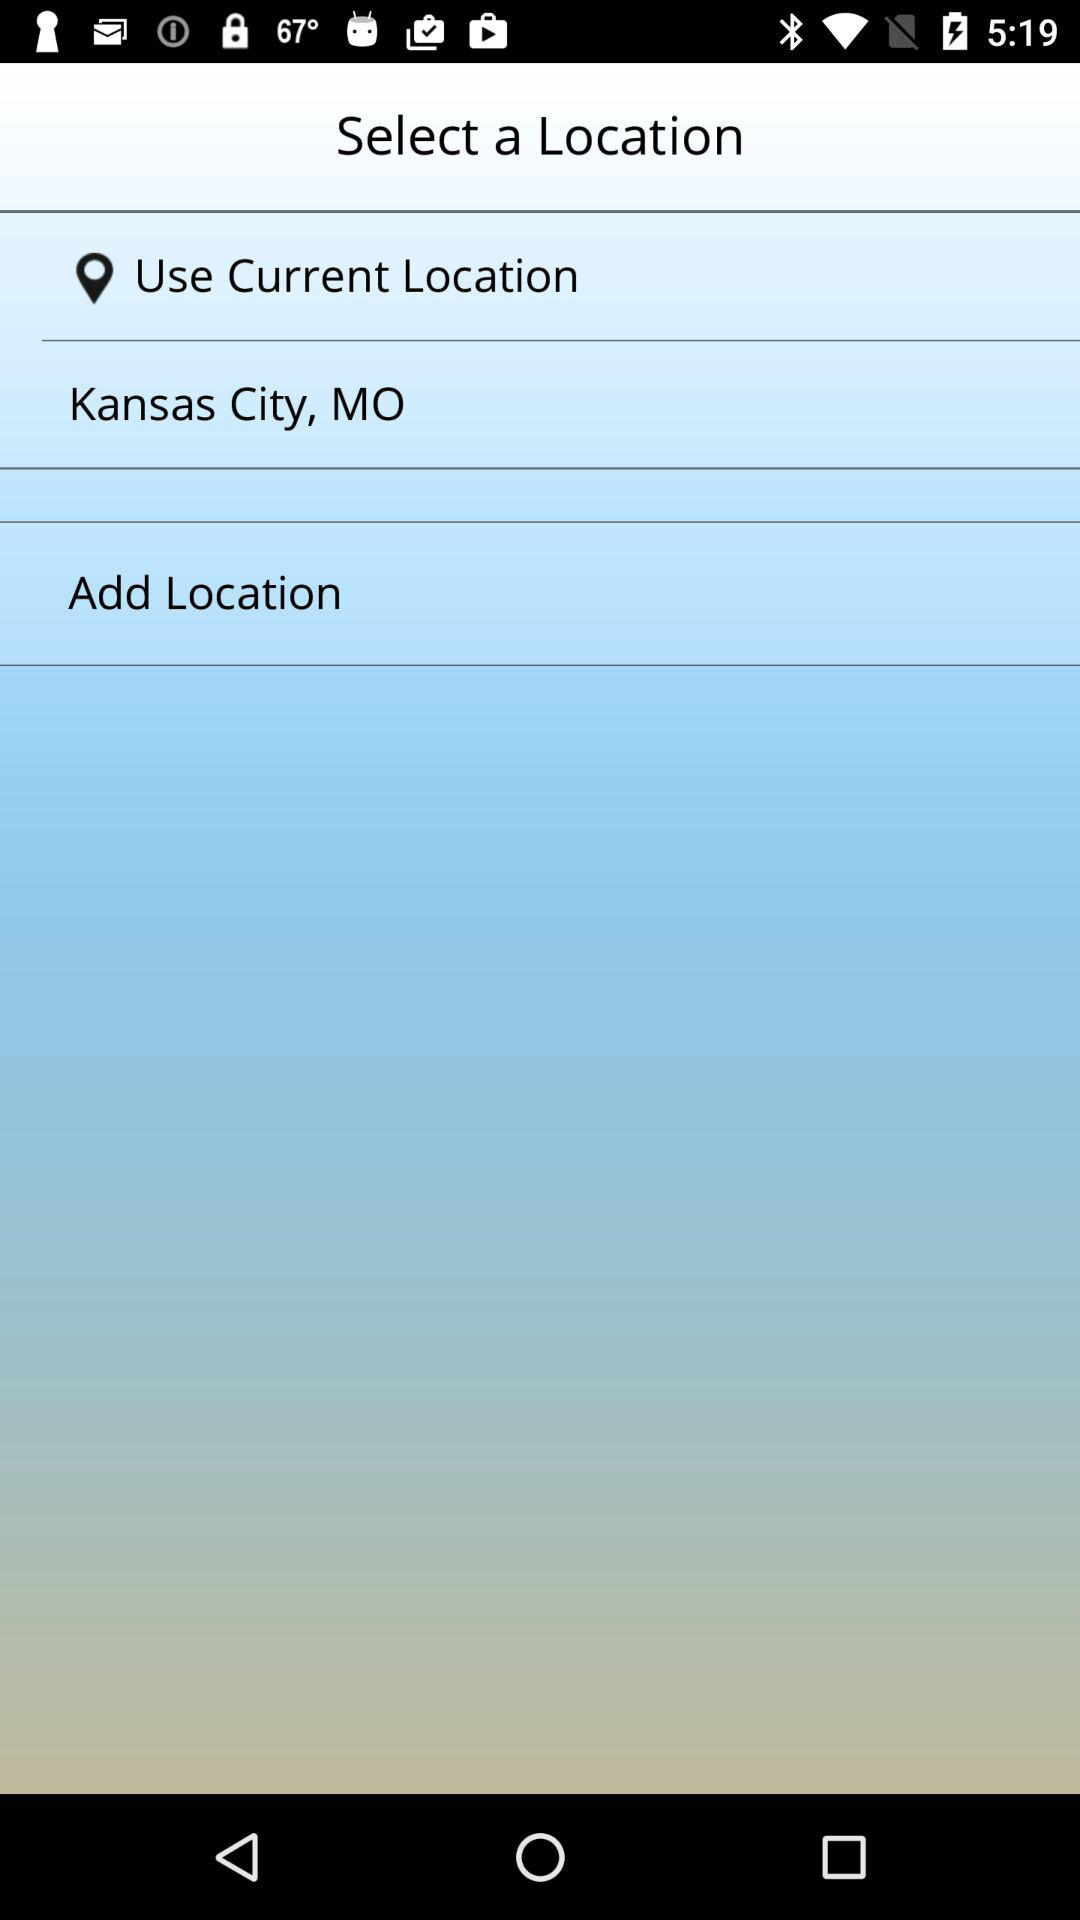What is the city name that has already been added? The city name that has already been added is Kansas City, MO. 